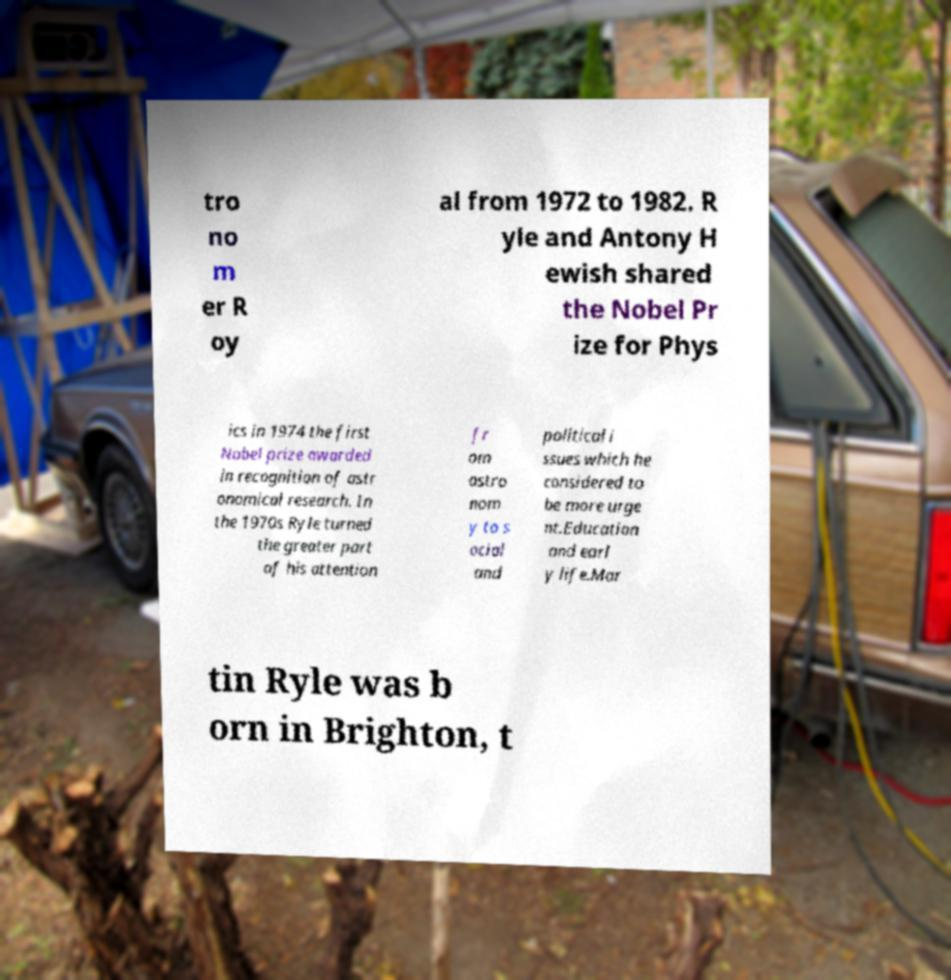What messages or text are displayed in this image? I need them in a readable, typed format. tro no m er R oy al from 1972 to 1982. R yle and Antony H ewish shared the Nobel Pr ize for Phys ics in 1974 the first Nobel prize awarded in recognition of astr onomical research. In the 1970s Ryle turned the greater part of his attention fr om astro nom y to s ocial and political i ssues which he considered to be more urge nt.Education and earl y life.Mar tin Ryle was b orn in Brighton, t 